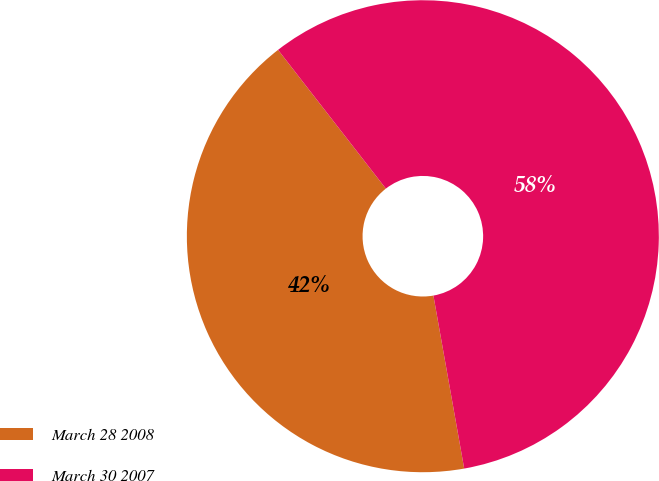Convert chart. <chart><loc_0><loc_0><loc_500><loc_500><pie_chart><fcel>March 28 2008<fcel>March 30 2007<nl><fcel>42.29%<fcel>57.71%<nl></chart> 